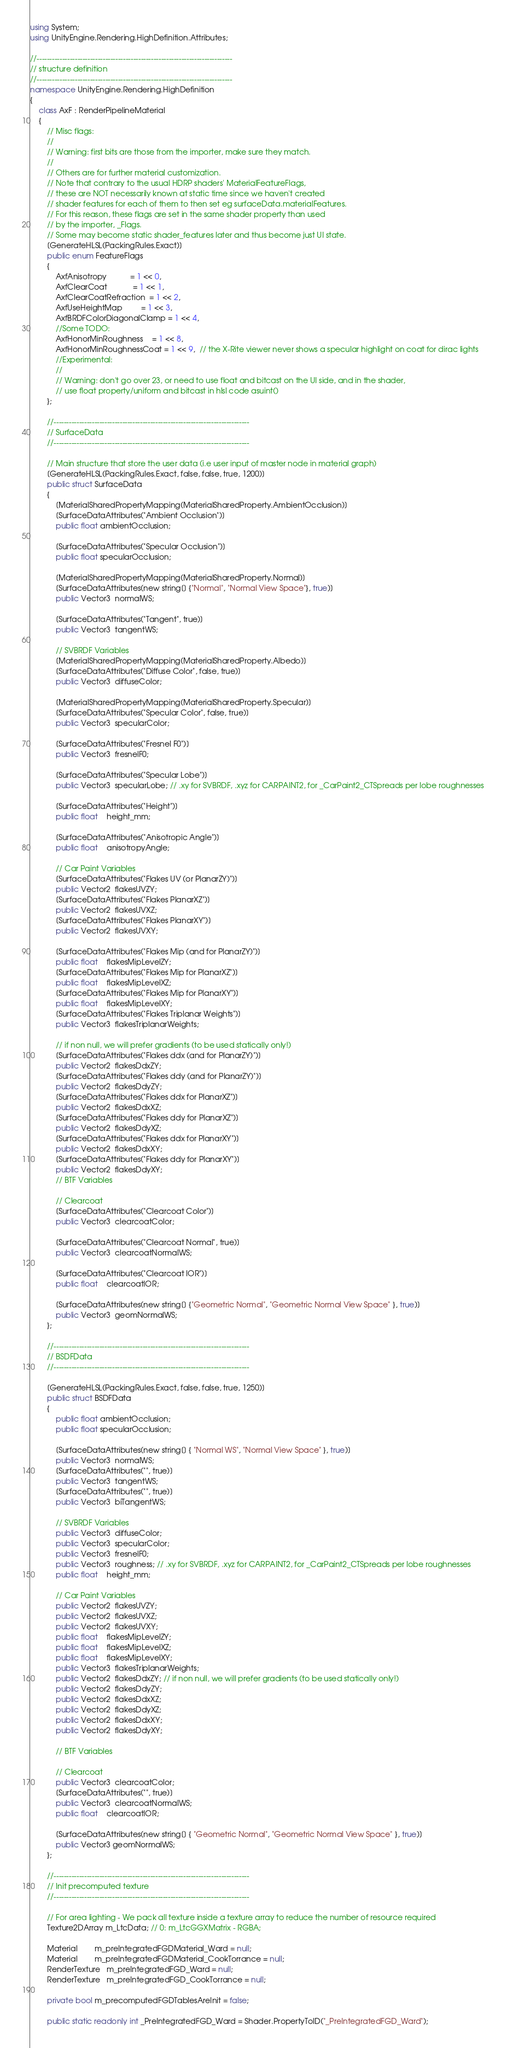Convert code to text. <code><loc_0><loc_0><loc_500><loc_500><_C#_>using System;
using UnityEngine.Rendering.HighDefinition.Attributes;

//-----------------------------------------------------------------------------
// structure definition
//-----------------------------------------------------------------------------
namespace UnityEngine.Rendering.HighDefinition
{
    class AxF : RenderPipelineMaterial
    {
        // Misc flags:
        //
        // Warning: first bits are those from the importer, make sure they match.
        //
        // Others are for further material customization.
        // Note that contrary to the usual HDRP shaders' MaterialFeatureFlags,
        // these are NOT necessarily known at static time since we haven't created
        // shader features for each of them to then set eg surfaceData.materialFeatures.
        // For this reason, these flags are set in the same shader property than used
        // by the importer, _Flags.
        // Some may become static shader_features later and thus become just UI state.
        [GenerateHLSL(PackingRules.Exact)]
        public enum FeatureFlags
        {
            AxfAnisotropy           = 1 << 0,
            AxfClearCoat            = 1 << 1,
            AxfClearCoatRefraction  = 1 << 2,
            AxfUseHeightMap         = 1 << 3,
            AxfBRDFColorDiagonalClamp = 1 << 4,
            //Some TODO:
            AxfHonorMinRoughness    = 1 << 8,
            AxfHonorMinRoughnessCoat = 1 << 9,  // the X-Rite viewer never shows a specular highlight on coat for dirac lights
            //Experimental:
            //
            // Warning: don't go over 23, or need to use float and bitcast on the UI side, and in the shader,
            // use float property/uniform and bitcast in hlsl code asuint()
        };

        //-----------------------------------------------------------------------------
        // SurfaceData
        //-----------------------------------------------------------------------------

        // Main structure that store the user data (i.e user input of master node in material graph)
        [GenerateHLSL(PackingRules.Exact, false, false, true, 1200)]
        public struct SurfaceData
        {
            [MaterialSharedPropertyMapping(MaterialSharedProperty.AmbientOcclusion)]
            [SurfaceDataAttributes("Ambient Occlusion")]
            public float ambientOcclusion;

            [SurfaceDataAttributes("Specular Occlusion")]
            public float specularOcclusion;

            [MaterialSharedPropertyMapping(MaterialSharedProperty.Normal)]
            [SurfaceDataAttributes(new string[] {"Normal", "Normal View Space"}, true)]
            public Vector3  normalWS;

            [SurfaceDataAttributes("Tangent", true)]
            public Vector3  tangentWS;

            // SVBRDF Variables
            [MaterialSharedPropertyMapping(MaterialSharedProperty.Albedo)]
            [SurfaceDataAttributes("Diffuse Color", false, true)]
            public Vector3  diffuseColor;

            [MaterialSharedPropertyMapping(MaterialSharedProperty.Specular)]
            [SurfaceDataAttributes("Specular Color", false, true)]
            public Vector3  specularColor;

            [SurfaceDataAttributes("Fresnel F0")]
            public Vector3  fresnelF0;

            [SurfaceDataAttributes("Specular Lobe")]
            public Vector3  specularLobe; // .xy for SVBRDF, .xyz for CARPAINT2, for _CarPaint2_CTSpreads per lobe roughnesses

            [SurfaceDataAttributes("Height")]
            public float    height_mm;

            [SurfaceDataAttributes("Anisotropic Angle")]
            public float    anisotropyAngle;

            // Car Paint Variables
            [SurfaceDataAttributes("Flakes UV (or PlanarZY)")]
            public Vector2  flakesUVZY;
            [SurfaceDataAttributes("Flakes PlanarXZ")]
            public Vector2  flakesUVXZ;
            [SurfaceDataAttributes("Flakes PlanarXY")]
            public Vector2  flakesUVXY;

            [SurfaceDataAttributes("Flakes Mip (and for PlanarZY)")]
            public float    flakesMipLevelZY;
            [SurfaceDataAttributes("Flakes Mip for PlanarXZ")]
            public float    flakesMipLevelXZ;
            [SurfaceDataAttributes("Flakes Mip for PlanarXY")]
            public float    flakesMipLevelXY;
            [SurfaceDataAttributes("Flakes Triplanar Weights")]
            public Vector3  flakesTriplanarWeights;

            // if non null, we will prefer gradients (to be used statically only!)
            [SurfaceDataAttributes("Flakes ddx (and for PlanarZY)")]
            public Vector2  flakesDdxZY;
            [SurfaceDataAttributes("Flakes ddy (and for PlanarZY)")]
            public Vector2  flakesDdyZY;
            [SurfaceDataAttributes("Flakes ddx for PlanarXZ")]
            public Vector2  flakesDdxXZ;
            [SurfaceDataAttributes("Flakes ddy for PlanarXZ")]
            public Vector2  flakesDdyXZ;
            [SurfaceDataAttributes("Flakes ddx for PlanarXY")]
            public Vector2  flakesDdxXY;
            [SurfaceDataAttributes("Flakes ddy for PlanarXY")]
            public Vector2  flakesDdyXY;
            // BTF Variables

            // Clearcoat
            [SurfaceDataAttributes("Clearcoat Color")]
            public Vector3  clearcoatColor;

            [SurfaceDataAttributes("Clearcoat Normal", true)]
            public Vector3  clearcoatNormalWS;

            [SurfaceDataAttributes("Clearcoat IOR")]
            public float    clearcoatIOR;

            [SurfaceDataAttributes(new string[] {"Geometric Normal", "Geometric Normal View Space" }, true)]
            public Vector3  geomNormalWS;
        };

        //-----------------------------------------------------------------------------
        // BSDFData
        //-----------------------------------------------------------------------------

        [GenerateHLSL(PackingRules.Exact, false, false, true, 1250)]
        public struct BSDFData
        {
            public float ambientOcclusion;
            public float specularOcclusion;

            [SurfaceDataAttributes(new string[] { "Normal WS", "Normal View Space" }, true)]
            public Vector3  normalWS;
            [SurfaceDataAttributes("", true)]
            public Vector3  tangentWS;
            [SurfaceDataAttributes("", true)]
            public Vector3  biTangentWS;

            // SVBRDF Variables
            public Vector3  diffuseColor;
            public Vector3  specularColor;
            public Vector3  fresnelF0;
            public Vector3  roughness; // .xy for SVBRDF, .xyz for CARPAINT2, for _CarPaint2_CTSpreads per lobe roughnesses
            public float    height_mm;

            // Car Paint Variables
            public Vector2  flakesUVZY;
            public Vector2  flakesUVXZ;
            public Vector2  flakesUVXY;
            public float    flakesMipLevelZY;
            public float    flakesMipLevelXZ;
            public float    flakesMipLevelXY;
            public Vector3  flakesTriplanarWeights;
            public Vector2  flakesDdxZY; // if non null, we will prefer gradients (to be used statically only!)
            public Vector2  flakesDdyZY;
            public Vector2  flakesDdxXZ;
            public Vector2  flakesDdyXZ;
            public Vector2  flakesDdxXY;
            public Vector2  flakesDdyXY;

            // BTF Variables

            // Clearcoat
            public Vector3  clearcoatColor;
            [SurfaceDataAttributes("", true)]
            public Vector3  clearcoatNormalWS;
            public float    clearcoatIOR;

            [SurfaceDataAttributes(new string[] { "Geometric Normal", "Geometric Normal View Space" }, true)]
            public Vector3 geomNormalWS;
        };

        //-----------------------------------------------------------------------------
        // Init precomputed texture
        //-----------------------------------------------------------------------------

        // For area lighting - We pack all texture inside a texture array to reduce the number of resource required
        Texture2DArray m_LtcData; // 0: m_LtcGGXMatrix - RGBA;

        Material        m_preIntegratedFGDMaterial_Ward = null;
        Material        m_preIntegratedFGDMaterial_CookTorrance = null;
        RenderTexture   m_preIntegratedFGD_Ward = null;
        RenderTexture   m_preIntegratedFGD_CookTorrance = null;

        private bool m_precomputedFGDTablesAreInit = false;

        public static readonly int _PreIntegratedFGD_Ward = Shader.PropertyToID("_PreIntegratedFGD_Ward");</code> 